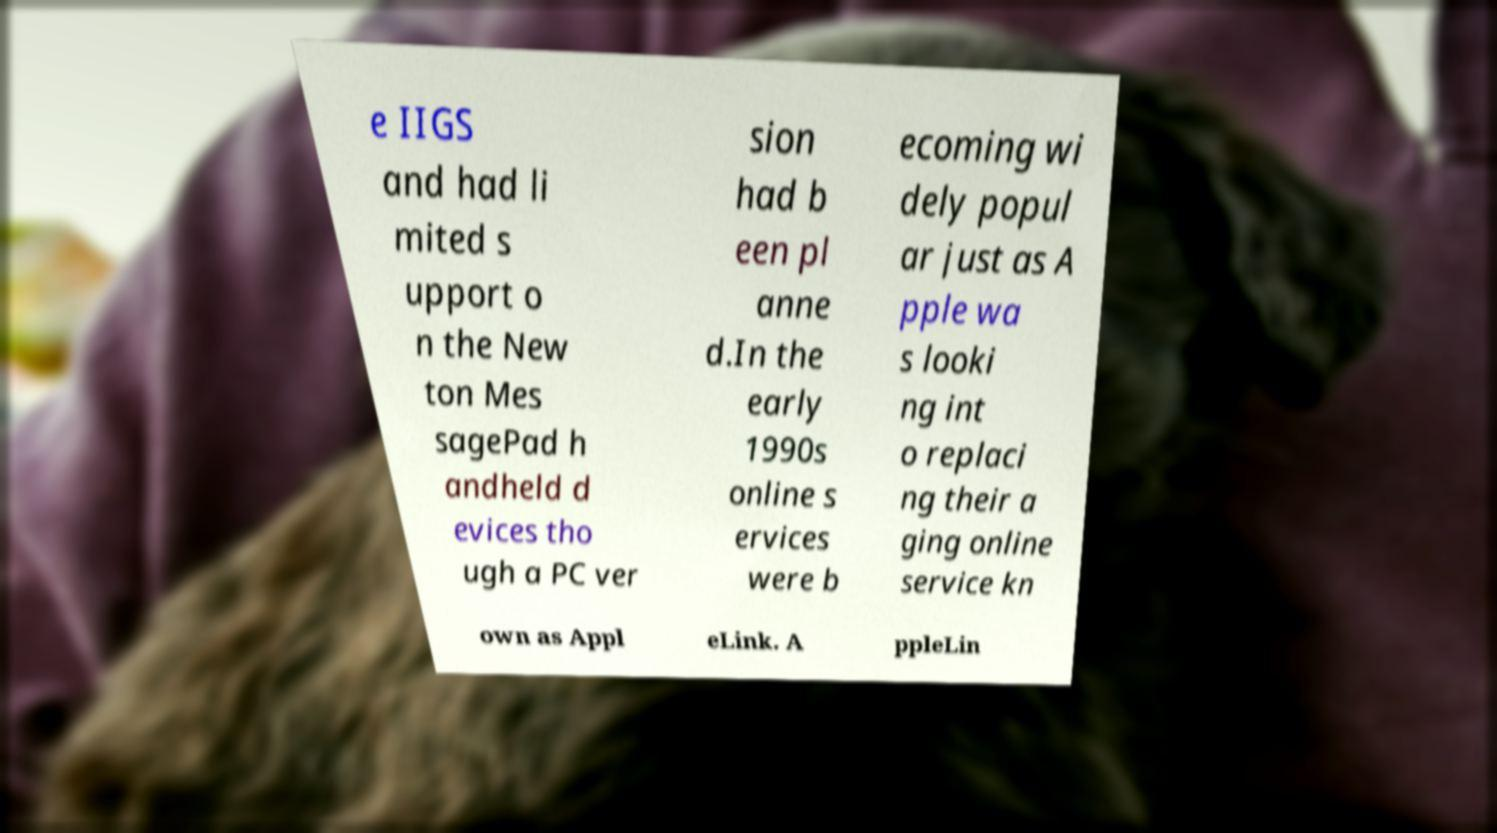Could you assist in decoding the text presented in this image and type it out clearly? e IIGS and had li mited s upport o n the New ton Mes sagePad h andheld d evices tho ugh a PC ver sion had b een pl anne d.In the early 1990s online s ervices were b ecoming wi dely popul ar just as A pple wa s looki ng int o replaci ng their a ging online service kn own as Appl eLink. A ppleLin 